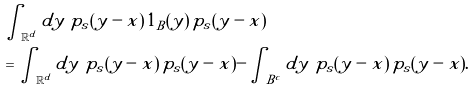Convert formula to latex. <formula><loc_0><loc_0><loc_500><loc_500>& \int _ { \mathbb { R } ^ { d } } d y \ p _ { s } ( y - x ) \, 1 _ { B } ( y ) \, p _ { s } ( y - x ) \\ & = \int _ { \mathbb { R } ^ { d } } d y \ p _ { s } ( y - x ) \, p _ { s } ( y - x ) - \int _ { B ^ { c } } d y \ p _ { s } ( y - x ) \, p _ { s } ( y - x ) .</formula> 